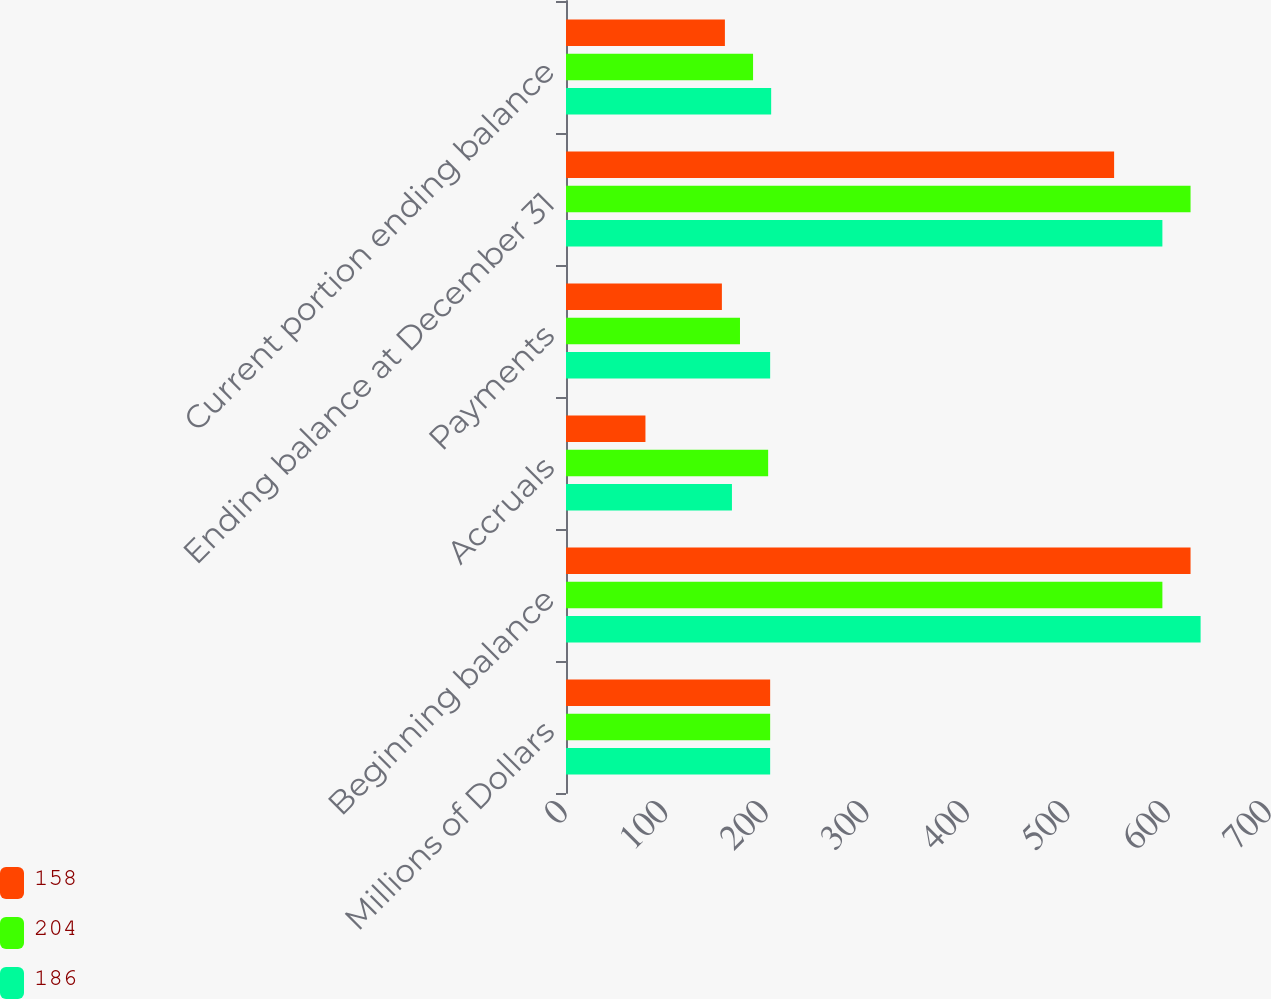Convert chart. <chart><loc_0><loc_0><loc_500><loc_500><stacked_bar_chart><ecel><fcel>Millions of Dollars<fcel>Beginning balance<fcel>Accruals<fcel>Payments<fcel>Ending balance at December 31<fcel>Current portion ending balance<nl><fcel>158<fcel>203<fcel>621<fcel>79<fcel>155<fcel>545<fcel>158<nl><fcel>204<fcel>203<fcel>593<fcel>201<fcel>173<fcel>621<fcel>186<nl><fcel>186<fcel>203<fcel>631<fcel>165<fcel>203<fcel>593<fcel>204<nl></chart> 